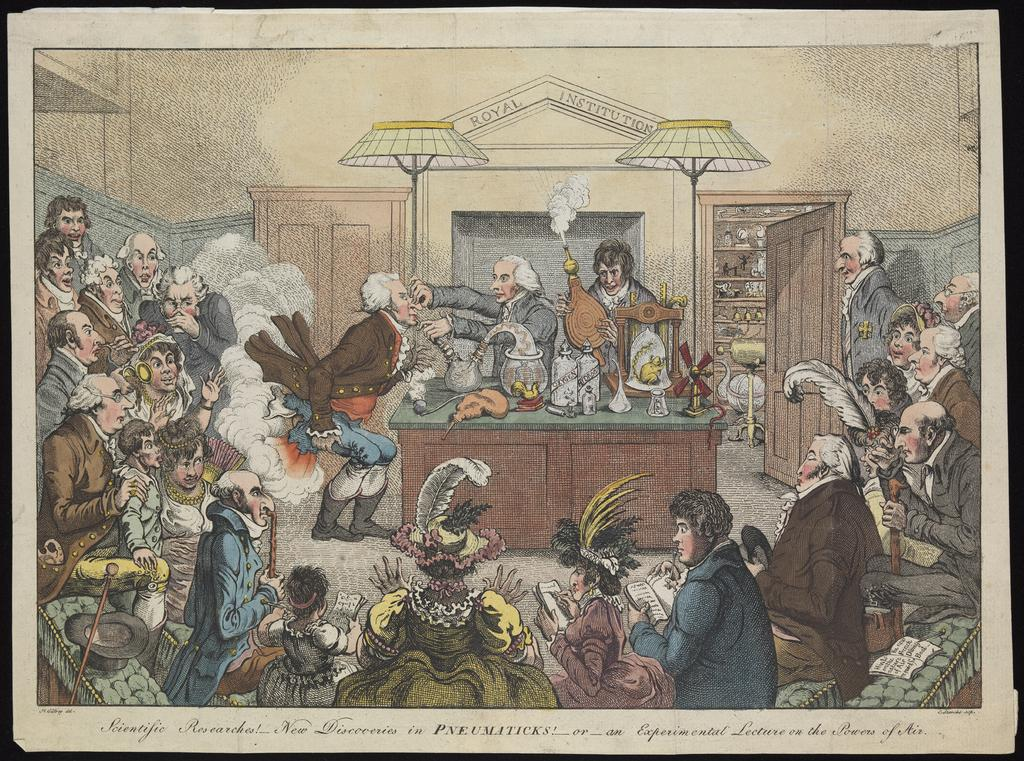<image>
Render a clear and concise summary of the photo. a drawing  of  the royal institution has many people in white wigs 